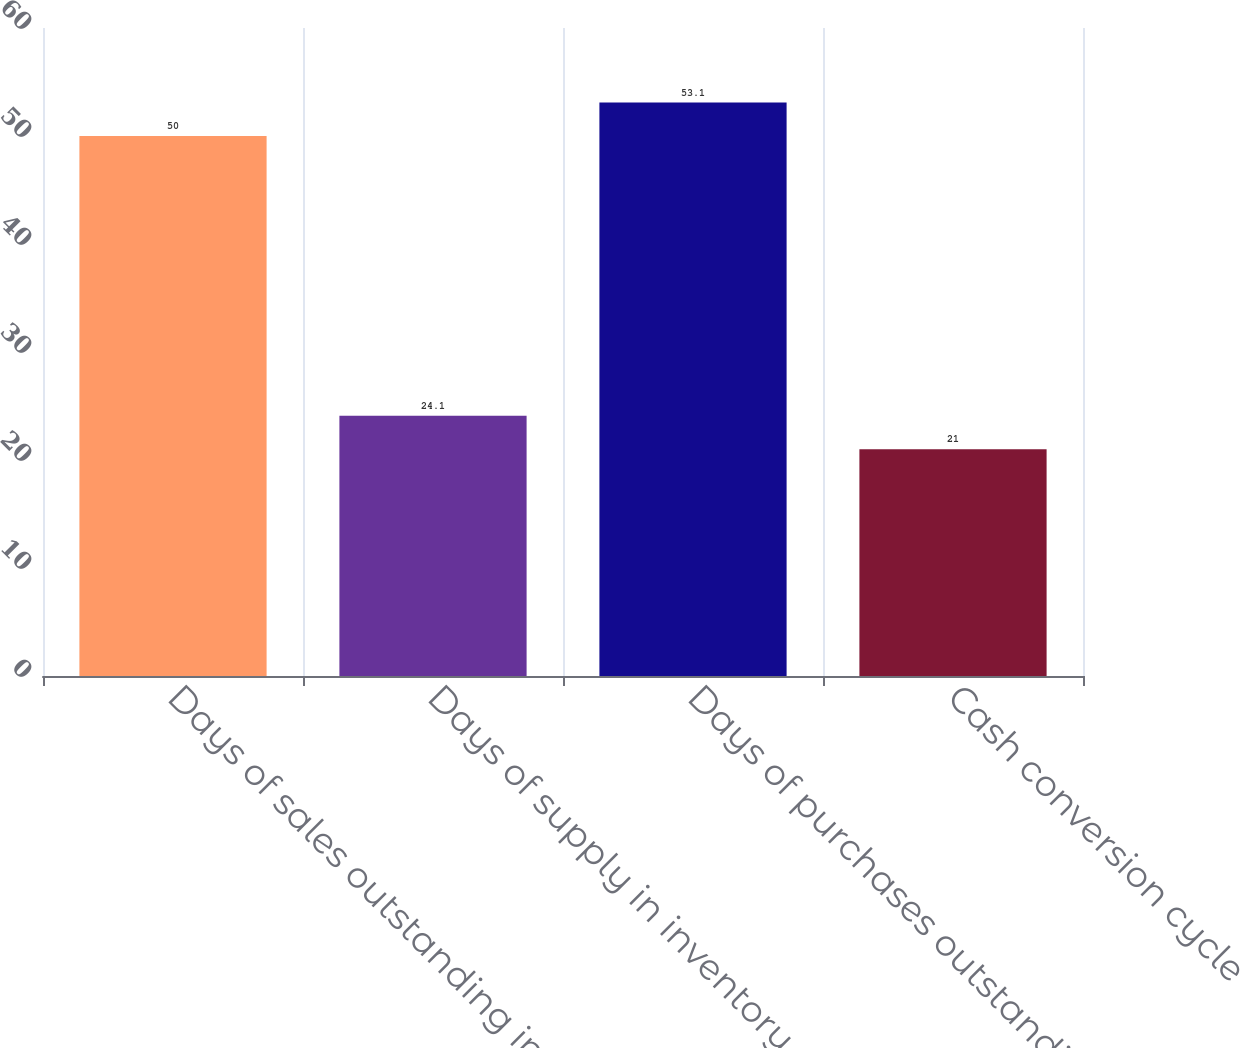Convert chart to OTSL. <chart><loc_0><loc_0><loc_500><loc_500><bar_chart><fcel>Days of sales outstanding in<fcel>Days of supply in inventory<fcel>Days of purchases outstanding<fcel>Cash conversion cycle<nl><fcel>50<fcel>24.1<fcel>53.1<fcel>21<nl></chart> 